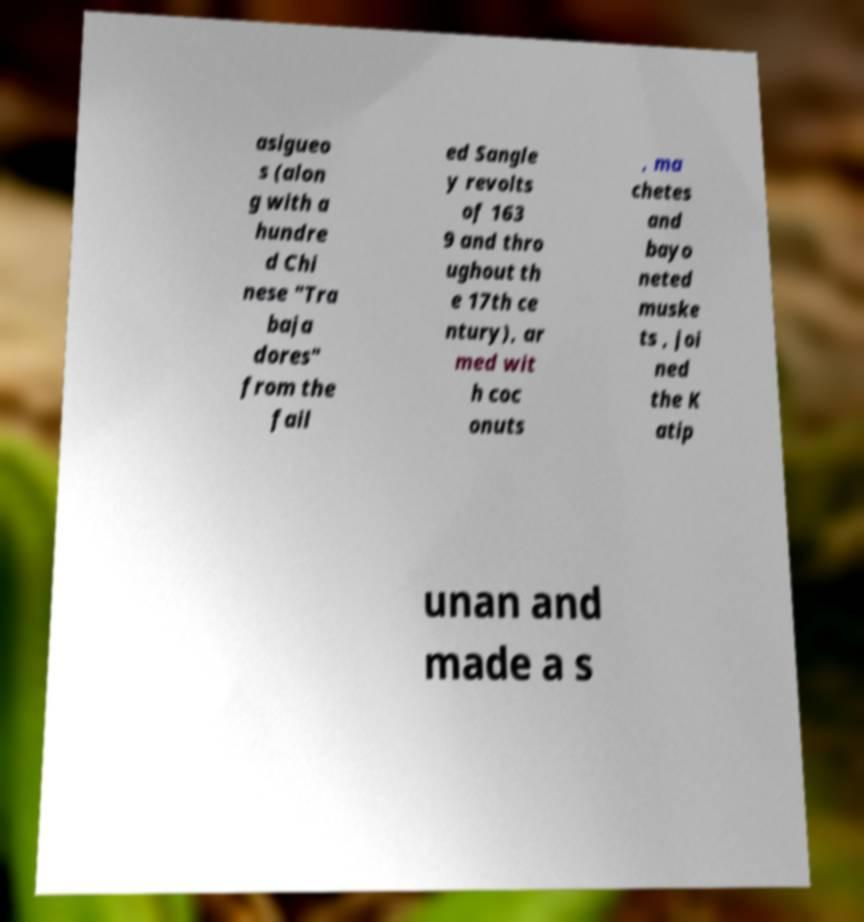Could you extract and type out the text from this image? asigueo s (alon g with a hundre d Chi nese "Tra baja dores" from the fail ed Sangle y revolts of 163 9 and thro ughout th e 17th ce ntury), ar med wit h coc onuts , ma chetes and bayo neted muske ts , joi ned the K atip unan and made a s 